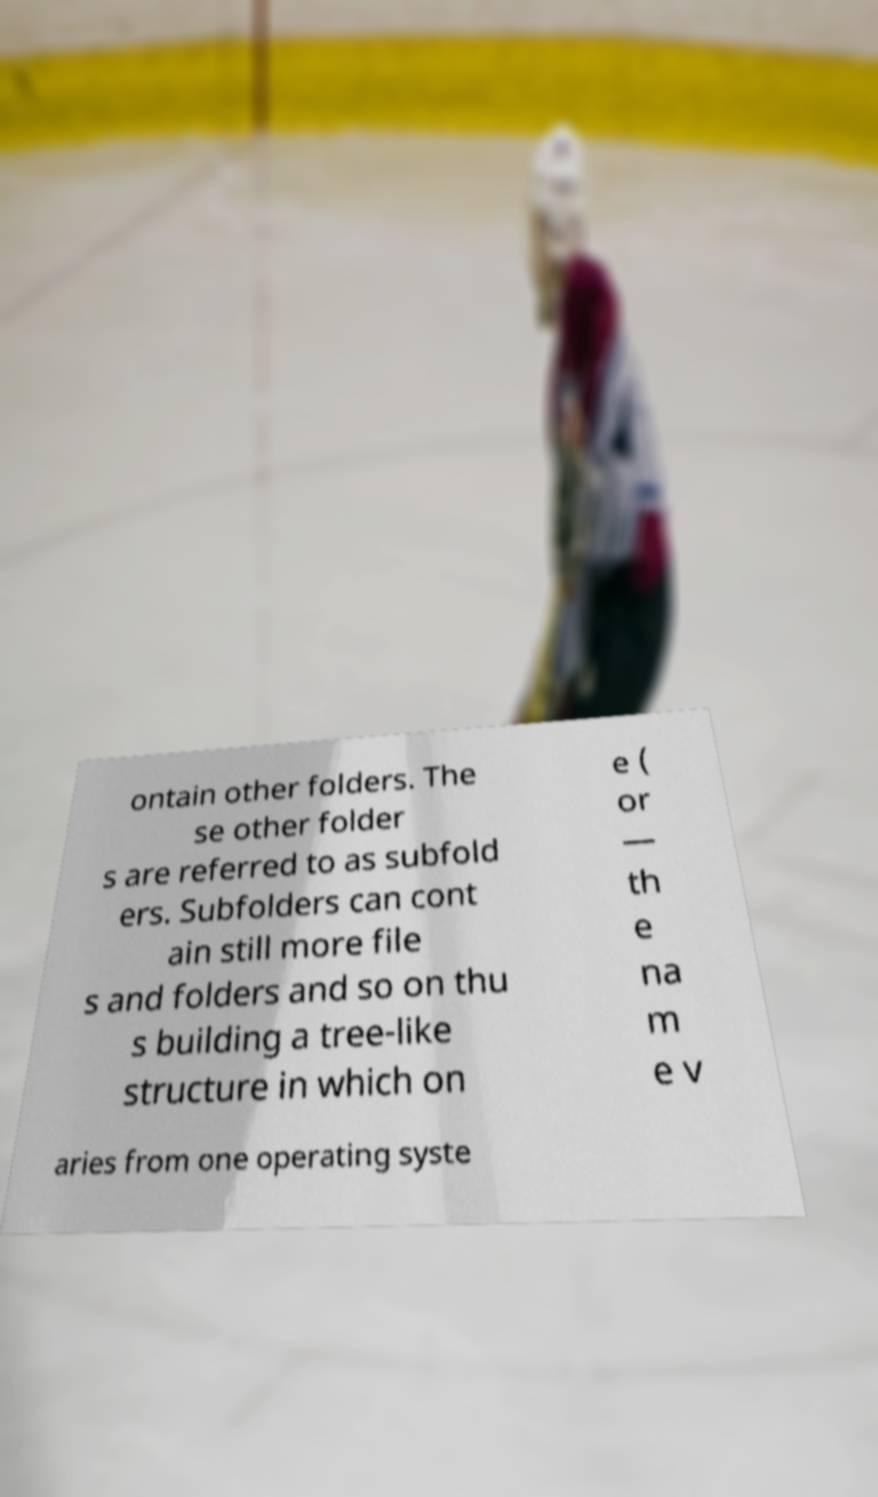Please identify and transcribe the text found in this image. ontain other folders. The se other folder s are referred to as subfold ers. Subfolders can cont ain still more file s and folders and so on thu s building a tree-like structure in which on e ( or — th e na m e v aries from one operating syste 